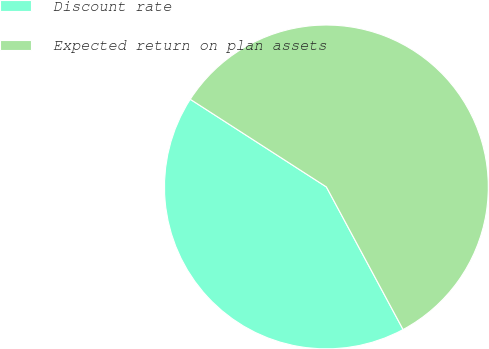Convert chart to OTSL. <chart><loc_0><loc_0><loc_500><loc_500><pie_chart><fcel>Discount rate<fcel>Expected return on plan assets<nl><fcel>41.96%<fcel>58.04%<nl></chart> 